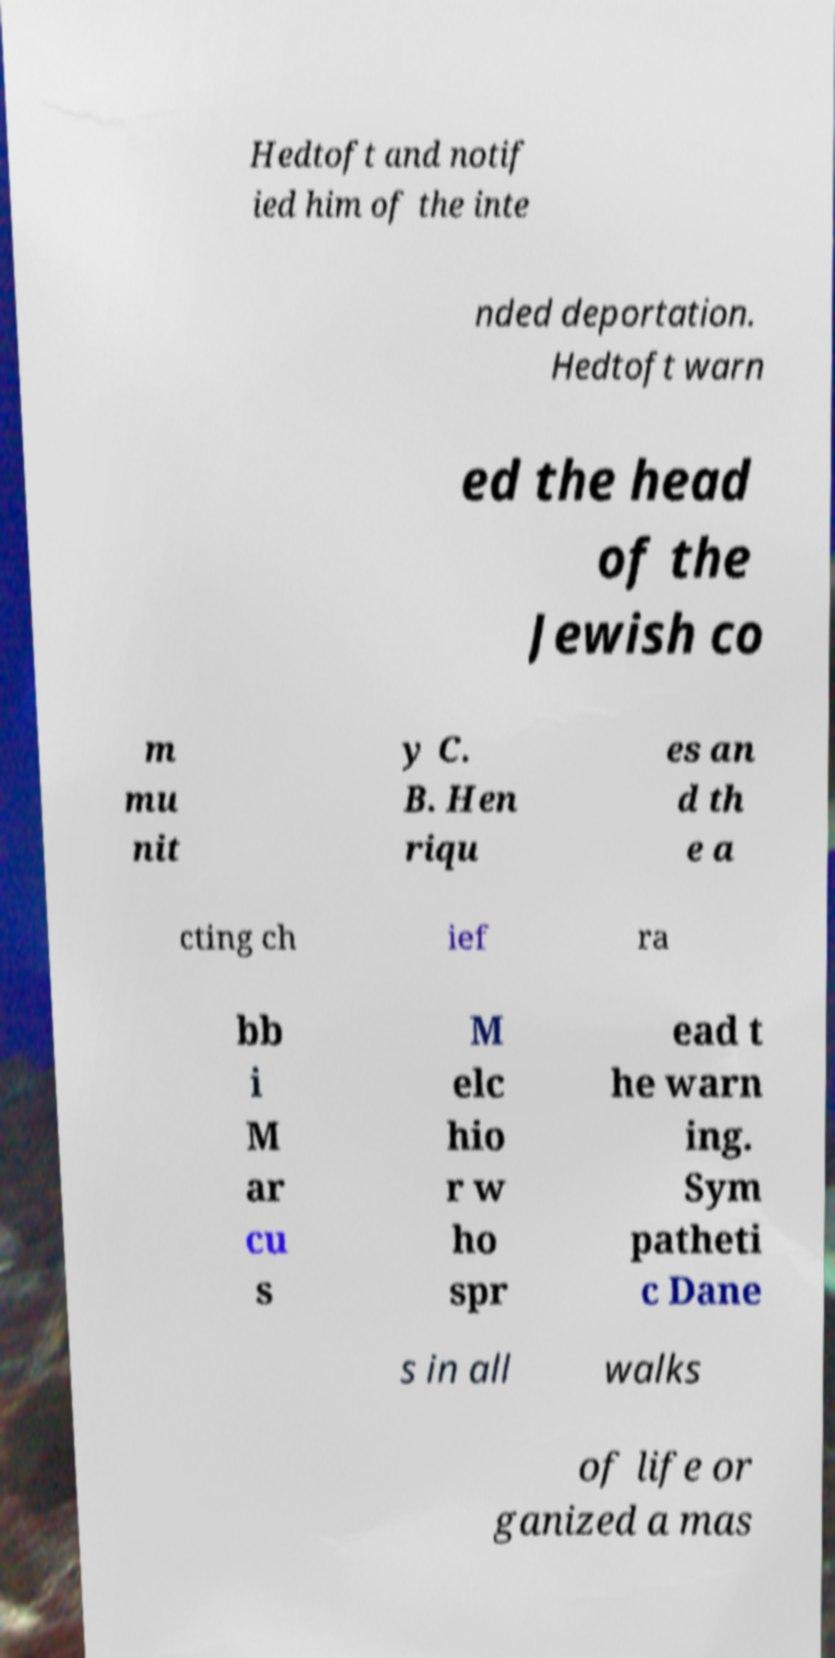I need the written content from this picture converted into text. Can you do that? Hedtoft and notif ied him of the inte nded deportation. Hedtoft warn ed the head of the Jewish co m mu nit y C. B. Hen riqu es an d th e a cting ch ief ra bb i M ar cu s M elc hio r w ho spr ead t he warn ing. Sym patheti c Dane s in all walks of life or ganized a mas 